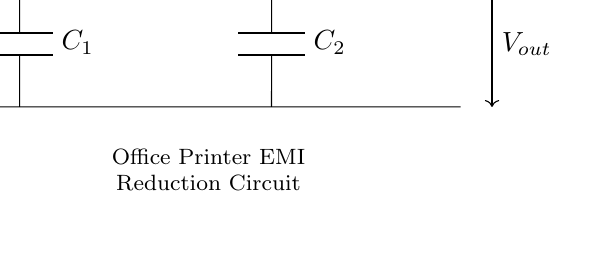What is the input voltage? The input voltage is indicated by `V_in`, which connects at the left side of the circuit diagram.
Answer: V_in What components are present in this EMI filter circuit? The components are two inductors, labeled as L_1 and L_2, and two capacitors, labeled as C_1 and C_2, as seen in the circuit.
Answer: L_1, L_2, C_1, C_2 How many reactive components are in the circuit? Reactive components are inductors and capacitors, and there are a total of four (two inductors and two capacitors) in this circuit.
Answer: Four What is the purpose of the inductors in this filter? Inductors in a filter circuit typically serve to block high-frequency signals while allowing lower frequencies to pass through, thereby reducing electromagnetic interference.
Answer: To block high frequencies What is the effect of the capacitors on the output voltage? The capacitors in the EMI filter are used to shunt high-frequency noise to ground, which helps to smooth out the output voltage and reduce interference.
Answer: Reduce interference What type of filter is represented by this circuit? This circuit is a low-pass filter, which allows low-frequency signals to pass through while attenuating high-frequency signals.
Answer: Low-pass filter 